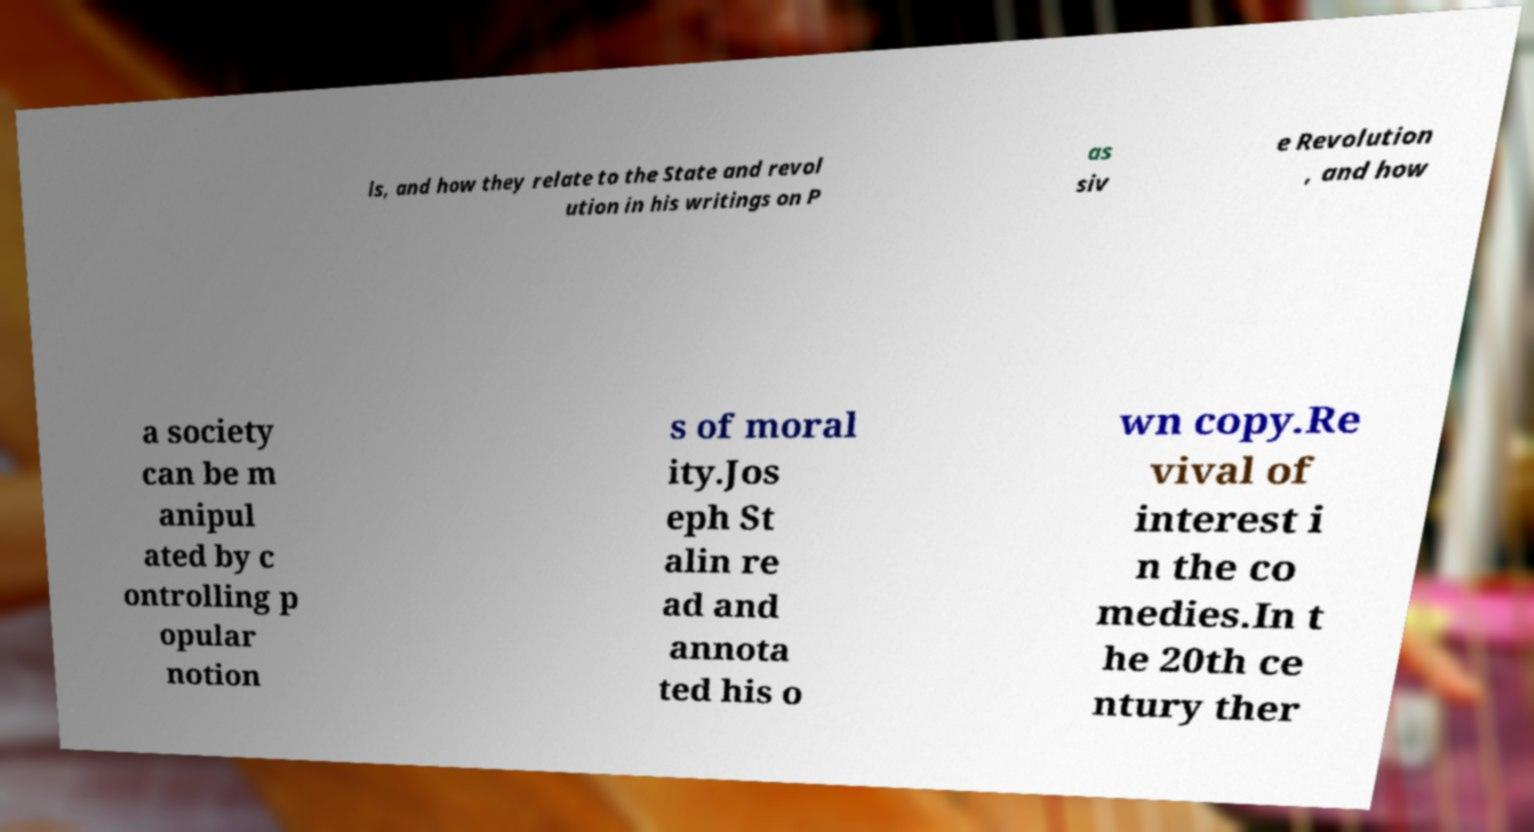What messages or text are displayed in this image? I need them in a readable, typed format. ls, and how they relate to the State and revol ution in his writings on P as siv e Revolution , and how a society can be m anipul ated by c ontrolling p opular notion s of moral ity.Jos eph St alin re ad and annota ted his o wn copy.Re vival of interest i n the co medies.In t he 20th ce ntury ther 